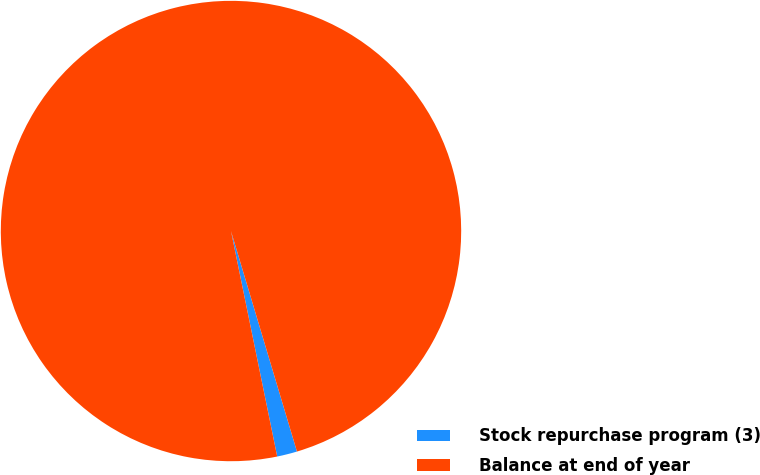Convert chart. <chart><loc_0><loc_0><loc_500><loc_500><pie_chart><fcel>Stock repurchase program (3)<fcel>Balance at end of year<nl><fcel>1.41%<fcel>98.59%<nl></chart> 